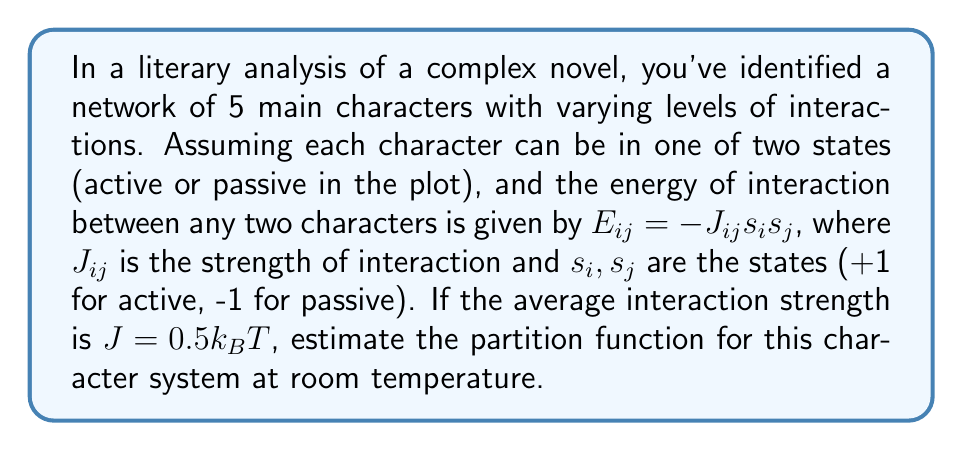Show me your answer to this math problem. To estimate the partition function for this system, we'll follow these steps:

1) The partition function for an Ising-like model is given by:

   $$Z = \sum_{\{s_i\}} e^{-\beta H}$$

   where $\beta = \frac{1}{k_BT}$ and $H$ is the Hamiltonian of the system.

2) For our character network, the Hamiltonian can be written as:

   $$H = -\sum_{i<j} J_{ij}s_is_j$$

3) With 5 characters, each in 2 possible states, we have $2^5 = 32$ possible configurations.

4) Given the average interaction strength $J = 0.5k_BT$, we can simplify $\beta J = 0.5$.

5) For a rough estimate, we can assume all interactions are equal to the average. With 5 characters, there are $\binom{5}{2} = 10$ possible interactions.

6) The energy for a single configuration can be estimated as:

   $$E \approx -10J(s_1s_2 + s_1s_3 + ... + s_4s_5)$$

7) The partition function becomes:

   $$Z \approx \sum_{\{s_i\}} e^{5\beta J(s_1s_2 + s_1s_3 + ... + s_4s_5)}$$

8) Given $\beta J = 0.5$, this simplifies to:

   $$Z \approx \sum_{\{s_i\}} e^{2.5(s_1s_2 + s_1s_3 + ... + s_4s_5)}$$

9) To get a numerical estimate, we can consider that in the most aligned state, all $s_i$ are the same, giving the maximum term $e^{25}$. In the least aligned state, we get $e^{-25}$.

10) A rough estimate for Z would be between these extremes, multiplied by the number of states:

    $$Z \approx 32 \cdot e^{12.5} \approx 7.2 \times 10^7$$
Answer: $Z \approx 7.2 \times 10^7$ 